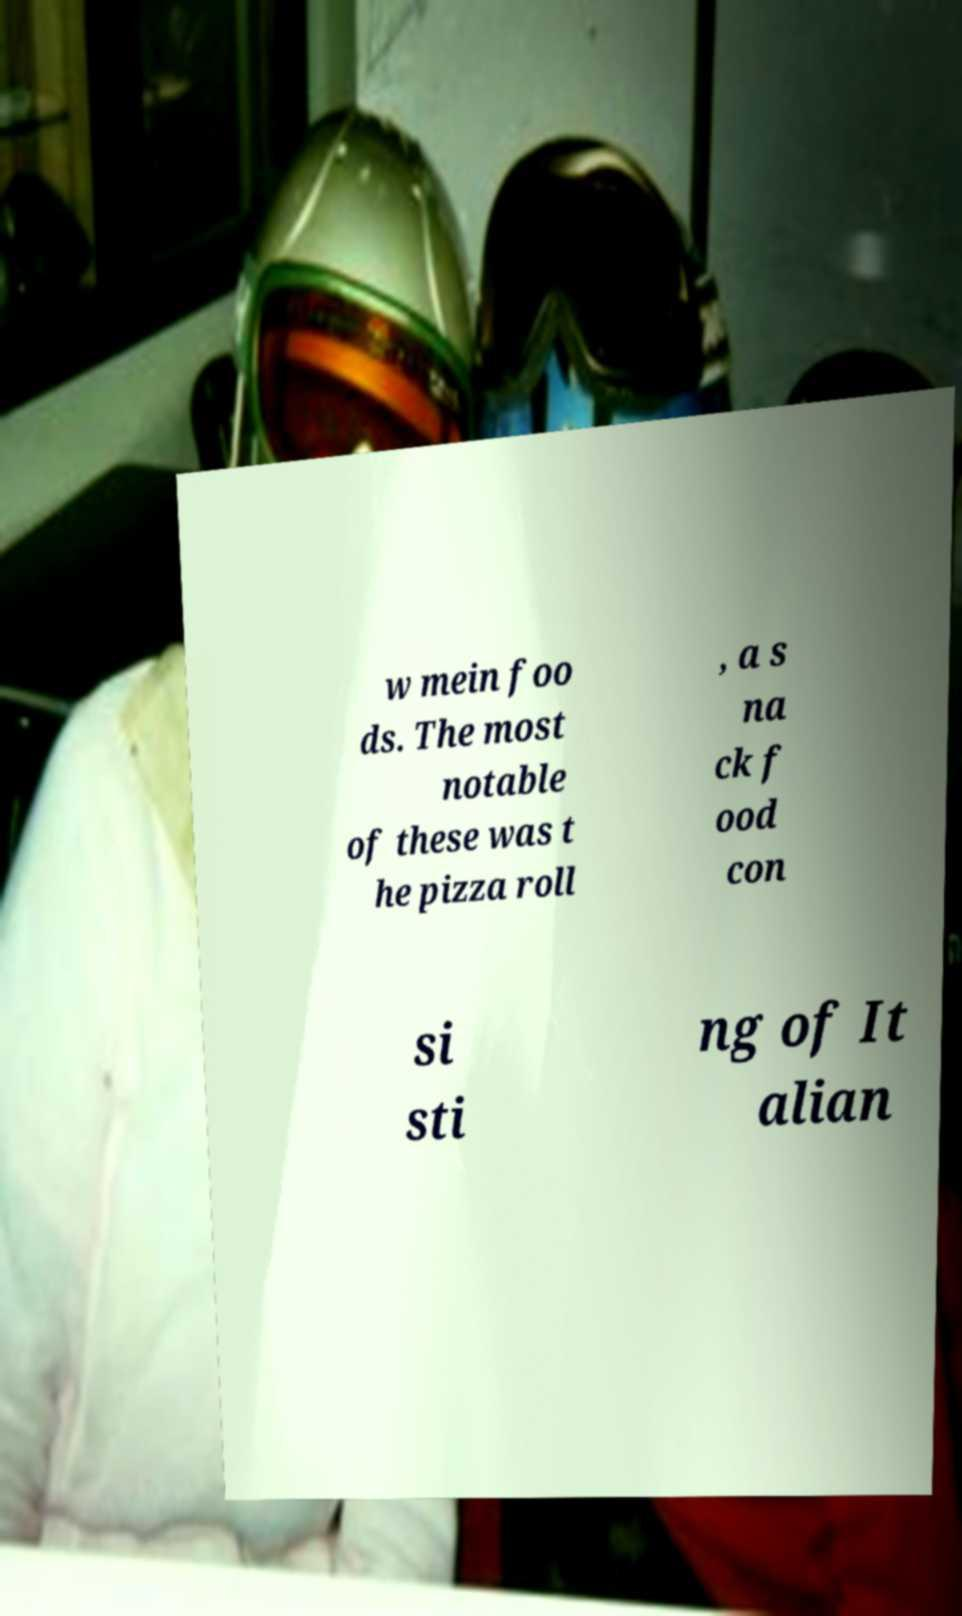Could you extract and type out the text from this image? w mein foo ds. The most notable of these was t he pizza roll , a s na ck f ood con si sti ng of It alian 